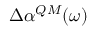<formula> <loc_0><loc_0><loc_500><loc_500>\Delta \alpha ^ { Q M } ( \omega )</formula> 